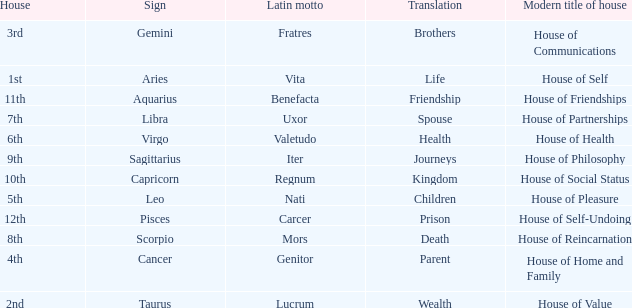What is the modern house title of the 1st house? House of Self. 